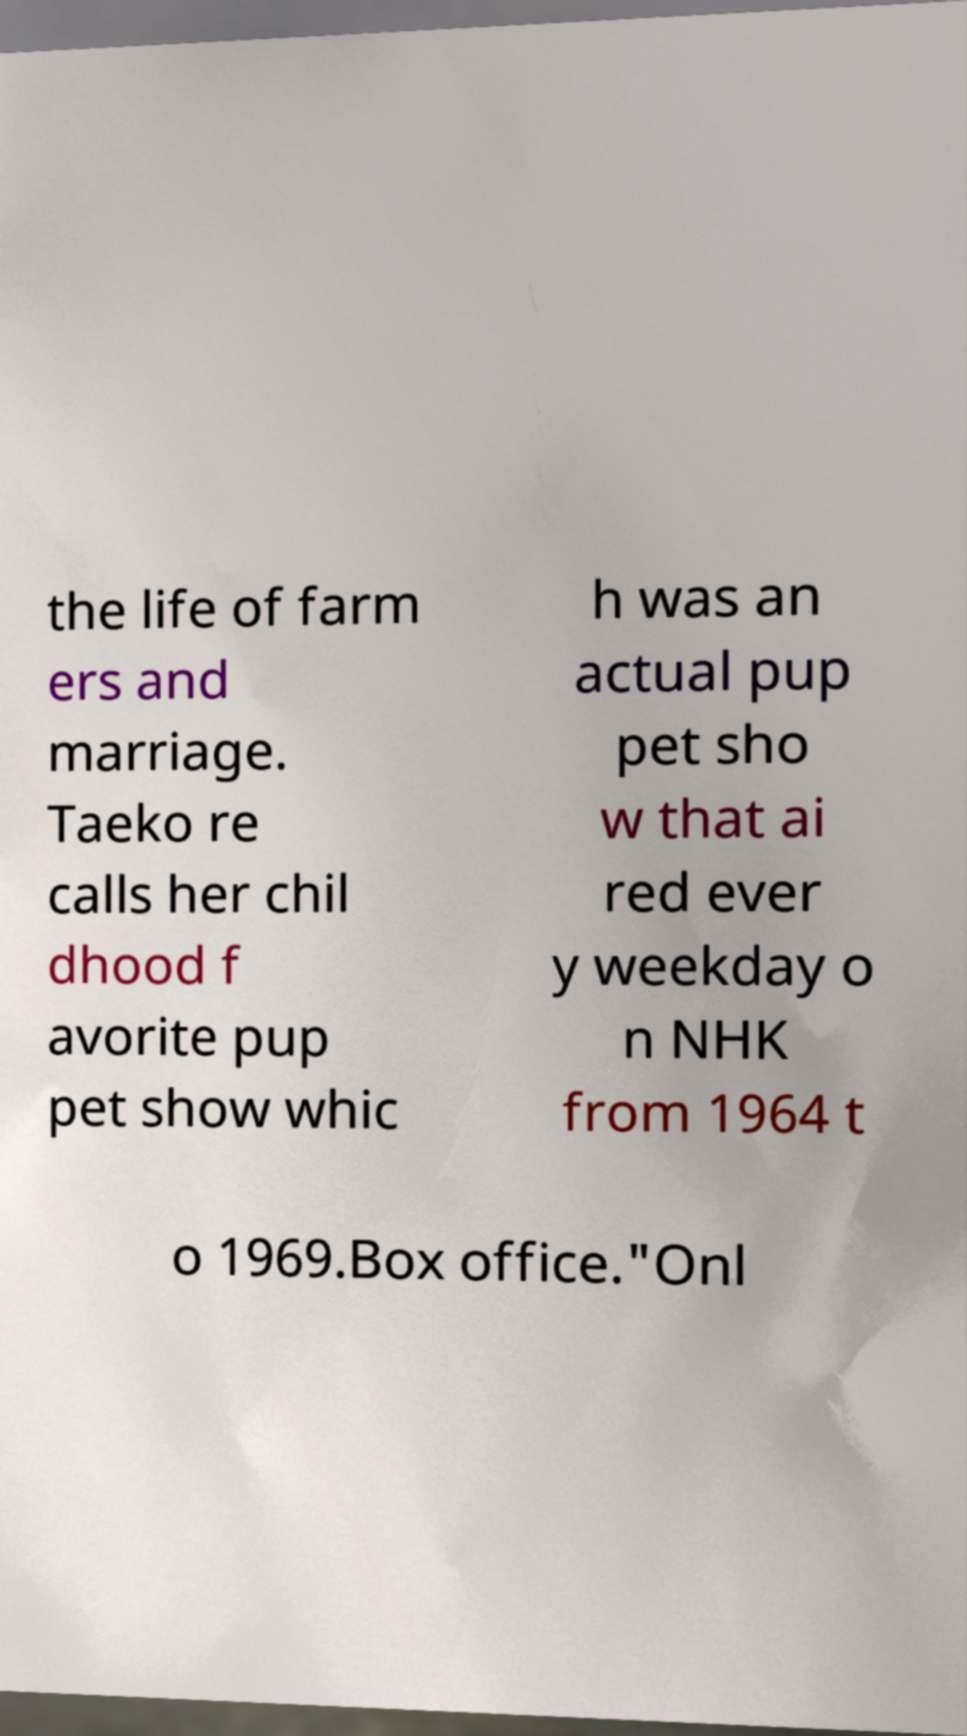Could you assist in decoding the text presented in this image and type it out clearly? the life of farm ers and marriage. Taeko re calls her chil dhood f avorite pup pet show whic h was an actual pup pet sho w that ai red ever y weekday o n NHK from 1964 t o 1969.Box office."Onl 